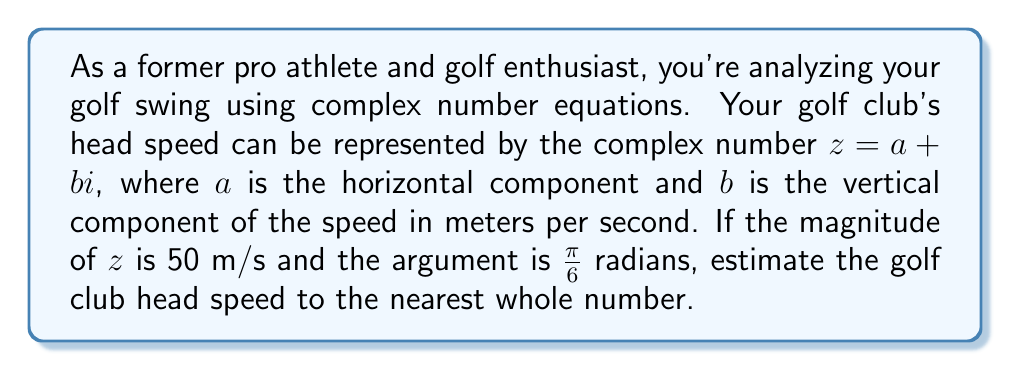Can you answer this question? To solve this problem, we'll use the polar form of complex numbers and convert it to rectangular form.

1) We're given that the magnitude $|z| = 50$ m/s and the argument $\arg(z) = \frac{\pi}{6}$ radians.

2) The polar form of a complex number is:
   $$z = r(\cos\theta + i\sin\theta)$$
   where $r$ is the magnitude and $\theta$ is the argument.

3) Substituting our values:
   $$z = 50(\cos\frac{\pi}{6} + i\sin\frac{\pi}{6})$$

4) Now, we need to convert this to rectangular form $a + bi$:
   $$a = 50\cos\frac{\pi}{6}$$
   $$b = 50\sin\frac{\pi}{6}$$

5) Calculate $a$:
   $$a = 50\cos\frac{\pi}{6} = 50 \cdot \frac{\sqrt{3}}{2} = 25\sqrt{3} \approx 43.30$$

6) Calculate $b$:
   $$b = 50\sin\frac{\pi}{6} = 50 \cdot \frac{1}{2} = 25$$

7) The golf club head speed is the magnitude of the complex number, which we already know is 50 m/s.

8) Rounding to the nearest whole number: 50 m/s.
Answer: 50 m/s 